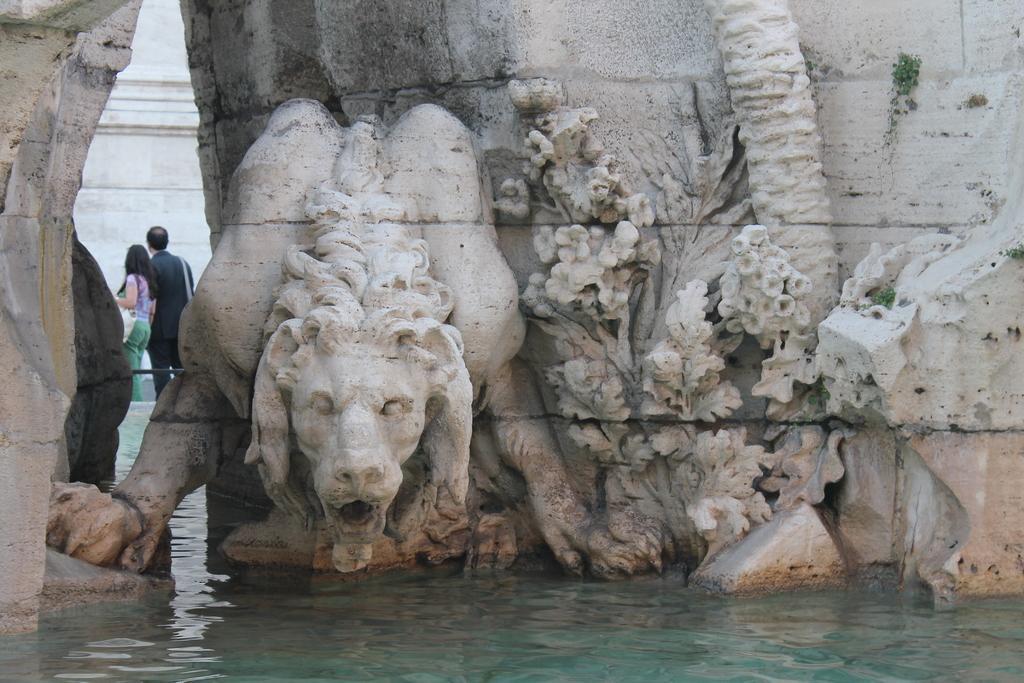Describe this image in one or two sentences. In this image there are sculptures on the wall. There is a woman carrying the bag. Beside her there is a person standing. Before them there is a wall. Bottom of the image there is water. 